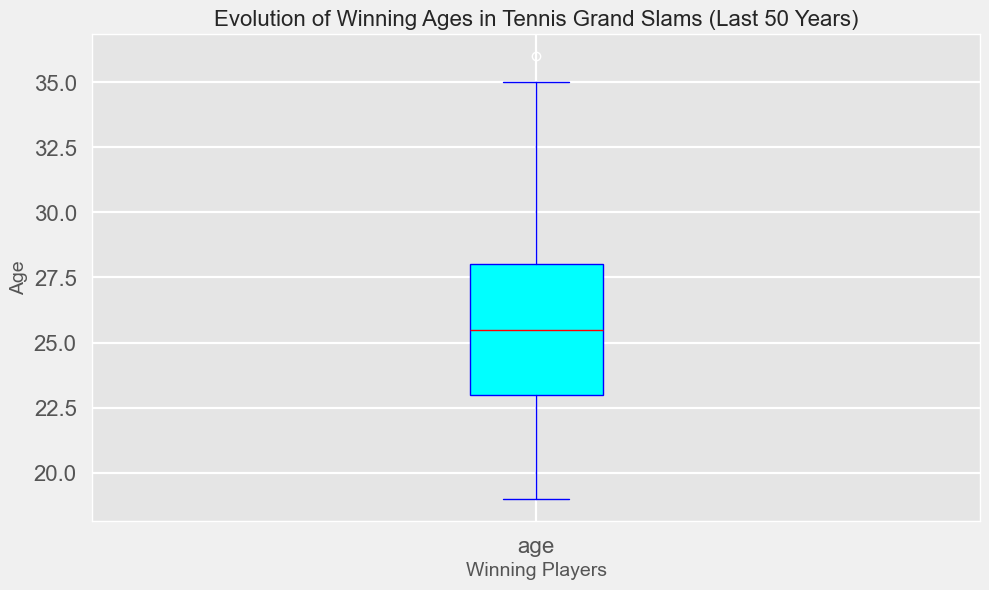What is the median age of winning players? To determine the median age, you look at the center value of the sorted ages. The median line is visually represented in the center of the box plot.
Answer: 26 What is the range of the winning ages? The range is calculated by subtracting the minimum value (bottom whisker) from the maximum value (top whisker) of the box plot.
Answer: 17 How does the age of the oldest winner compare to the youngest winner? The oldest winner's age is represented by the top whisker, and the youngest winner's age is represented by the bottom whisker. Comparing these visually will show that the oldest winner is significantly older.
Answer: The oldest winner is older by 17 years What is the interquartile range (IQR) of the winning ages? IQR is defined as the difference between the third quartile (top edge of the box) and the first quartile (bottom edge of the box).
Answer: 5 Is the median winning age closer to the first quartile or the third quartile? By observing the box plot, you see the position of the median line relative to the quartiles. The median is closer to the third quartile since it is slightly above the middle of the box.
Answer: Third quartile Are there any outliers in the winning ages data? Outliers are depicted as individual points that fall outside of the whiskers in a box plot. Upon examining the plot, there is one dot representing an outlier.
Answer: Yes What is the most frequent age range for winning players? The length of the box (which represents the IQR) visualizes the concentration of data points. The bulk of winning ages lies within this box.
Answer: 22 to 27 How does the median age of winning players compare to the average? Median is depicted as the red line in the box plot, whereas average may require more context. By observation and general properties of data, the median is often a good indicator similar to the mean.
Answer: Similar Among the winning ages, which age appears to be more common visually? Commonness can be inferred from the density within the box plot. The median age, represented by the red line, suggests commonality visually.
Answer: 26 